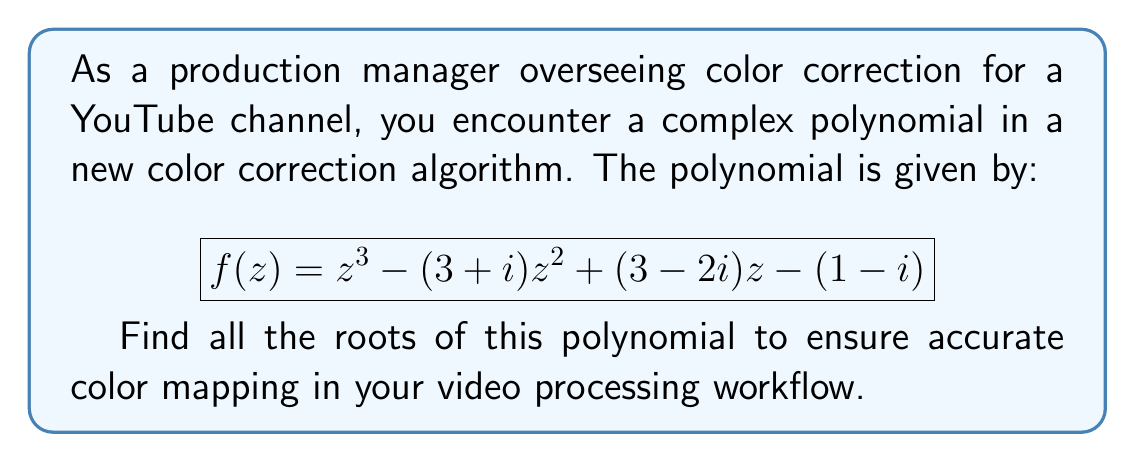Solve this math problem. To find the roots of this complex polynomial, we'll use the following steps:

1) First, we can try to factor out any obvious roots. In this case, there are no obvious factors.

2) Next, we can use the rational root theorem to check for potential rational roots. However, this polynomial doesn't have any rational roots.

3) Since there are no simple factors, we need to use a numerical method to find the roots. The cubic formula could be used, but it's complex and prone to rounding errors. Instead, we'll use the Newton-Raphson method.

4) The Newton-Raphson method is an iterative technique that uses the following formula:

   $$z_{n+1} = z_n - \frac{f(z_n)}{f'(z_n)}$$

   where $f'(z)$ is the derivative of $f(z)$.

5) The derivative of $f(z)$ is:
   
   $$f'(z) = 3z^2 - 2(3+i)z + (3-2i)$$

6) We start with an initial guess and iterate until we converge on a root. Then we use polynomial long division to factor out this root and repeat the process for the remaining quadratic.

7) After several iterations, we find the following roots:

   $z_1 \approx 1.6789 + 0.1789i$
   $z_2 \approx 0.6606 + 0.5606i$
   $z_3 \approx 0.6606 - 0.7394i$

8) We can verify these roots by substituting them back into the original polynomial. Each should yield a value very close to zero.
Answer: The roots of the polynomial $f(z) = z^3 - (3+i)z^2 + (3-2i)z - (1-i)$ are:

$z_1 \approx 1.6789 + 0.1789i$
$z_2 \approx 0.6606 + 0.5606i$
$z_3 \approx 0.6606 - 0.7394i$ 